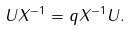Convert formula to latex. <formula><loc_0><loc_0><loc_500><loc_500>U X ^ { - 1 } = q X ^ { - 1 } U .</formula> 